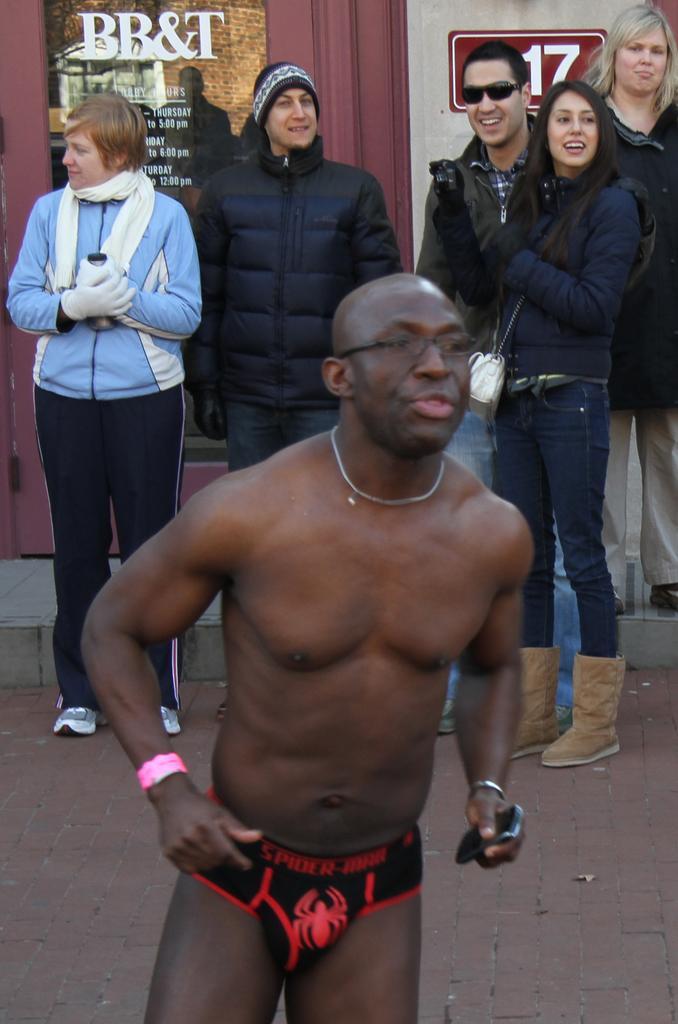In one or two sentences, can you explain what this image depicts? In this picture we can see a group of people standing on the road. 